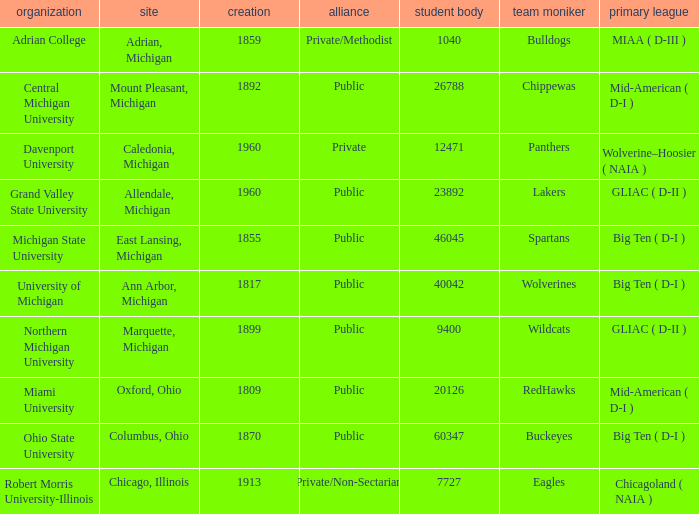How many primary conferences were held in Allendale, Michigan? 1.0. Could you parse the entire table? {'header': ['organization', 'site', 'creation', 'alliance', 'student body', 'team moniker', 'primary league'], 'rows': [['Adrian College', 'Adrian, Michigan', '1859', 'Private/Methodist', '1040', 'Bulldogs', 'MIAA ( D-III )'], ['Central Michigan University', 'Mount Pleasant, Michigan', '1892', 'Public', '26788', 'Chippewas', 'Mid-American ( D-I )'], ['Davenport University', 'Caledonia, Michigan', '1960', 'Private', '12471', 'Panthers', 'Wolverine–Hoosier ( NAIA )'], ['Grand Valley State University', 'Allendale, Michigan', '1960', 'Public', '23892', 'Lakers', 'GLIAC ( D-II )'], ['Michigan State University', 'East Lansing, Michigan', '1855', 'Public', '46045', 'Spartans', 'Big Ten ( D-I )'], ['University of Michigan', 'Ann Arbor, Michigan', '1817', 'Public', '40042', 'Wolverines', 'Big Ten ( D-I )'], ['Northern Michigan University', 'Marquette, Michigan', '1899', 'Public', '9400', 'Wildcats', 'GLIAC ( D-II )'], ['Miami University', 'Oxford, Ohio', '1809', 'Public', '20126', 'RedHawks', 'Mid-American ( D-I )'], ['Ohio State University', 'Columbus, Ohio', '1870', 'Public', '60347', 'Buckeyes', 'Big Ten ( D-I )'], ['Robert Morris University-Illinois', 'Chicago, Illinois', '1913', 'Private/Non-Sectarian', '7727', 'Eagles', 'Chicagoland ( NAIA )']]} 